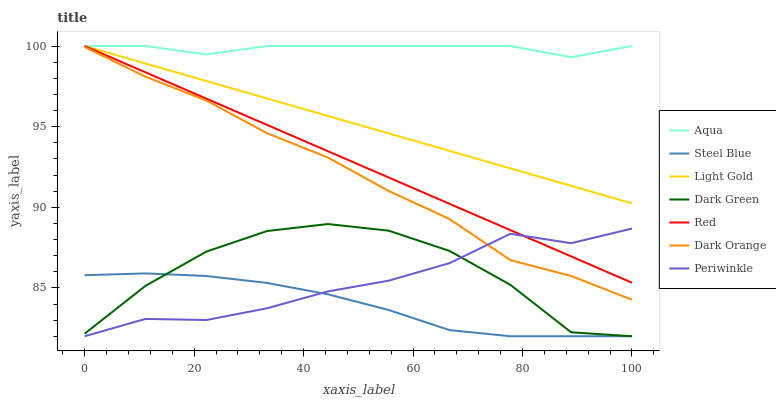Does Steel Blue have the minimum area under the curve?
Answer yes or no. Yes. Does Aqua have the maximum area under the curve?
Answer yes or no. Yes. Does Aqua have the minimum area under the curve?
Answer yes or no. No. Does Steel Blue have the maximum area under the curve?
Answer yes or no. No. Is Light Gold the smoothest?
Answer yes or no. Yes. Is Dark Green the roughest?
Answer yes or no. Yes. Is Aqua the smoothest?
Answer yes or no. No. Is Aqua the roughest?
Answer yes or no. No. Does Steel Blue have the lowest value?
Answer yes or no. Yes. Does Aqua have the lowest value?
Answer yes or no. No. Does Red have the highest value?
Answer yes or no. Yes. Does Steel Blue have the highest value?
Answer yes or no. No. Is Dark Orange less than Light Gold?
Answer yes or no. Yes. Is Aqua greater than Steel Blue?
Answer yes or no. Yes. Does Red intersect Periwinkle?
Answer yes or no. Yes. Is Red less than Periwinkle?
Answer yes or no. No. Is Red greater than Periwinkle?
Answer yes or no. No. Does Dark Orange intersect Light Gold?
Answer yes or no. No. 